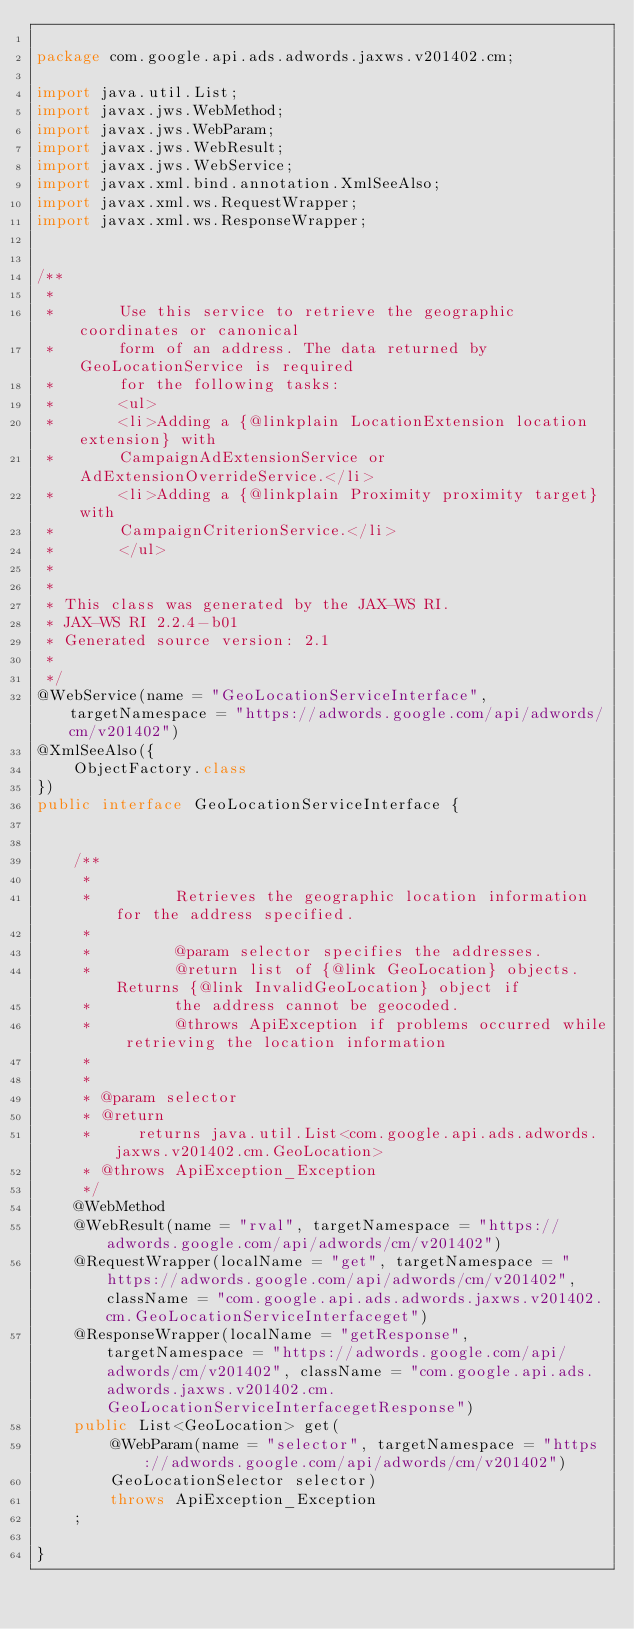Convert code to text. <code><loc_0><loc_0><loc_500><loc_500><_Java_>
package com.google.api.ads.adwords.jaxws.v201402.cm;

import java.util.List;
import javax.jws.WebMethod;
import javax.jws.WebParam;
import javax.jws.WebResult;
import javax.jws.WebService;
import javax.xml.bind.annotation.XmlSeeAlso;
import javax.xml.ws.RequestWrapper;
import javax.xml.ws.ResponseWrapper;


/**
 * 
 *       Use this service to retrieve the geographic coordinates or canonical
 *       form of an address. The data returned by GeoLocationService is required
 *       for the following tasks:
 *       <ul>
 *       <li>Adding a {@linkplain LocationExtension location extension} with
 *       CampaignAdExtensionService or AdExtensionOverrideService.</li>
 *       <li>Adding a {@linkplain Proximity proximity target} with
 *       CampaignCriterionService.</li>
 *       </ul>
 *     
 * 
 * This class was generated by the JAX-WS RI.
 * JAX-WS RI 2.2.4-b01
 * Generated source version: 2.1
 * 
 */
@WebService(name = "GeoLocationServiceInterface", targetNamespace = "https://adwords.google.com/api/adwords/cm/v201402")
@XmlSeeAlso({
    ObjectFactory.class
})
public interface GeoLocationServiceInterface {


    /**
     * 
     *         Retrieves the geographic location information for the address specified.
     *         
     *         @param selector specifies the addresses.
     *         @return list of {@link GeoLocation} objects. Returns {@link InvalidGeoLocation} object if
     *         the address cannot be geocoded.
     *         @throws ApiException if problems occurred while retrieving the location information
     *       
     * 
     * @param selector
     * @return
     *     returns java.util.List<com.google.api.ads.adwords.jaxws.v201402.cm.GeoLocation>
     * @throws ApiException_Exception
     */
    @WebMethod
    @WebResult(name = "rval", targetNamespace = "https://adwords.google.com/api/adwords/cm/v201402")
    @RequestWrapper(localName = "get", targetNamespace = "https://adwords.google.com/api/adwords/cm/v201402", className = "com.google.api.ads.adwords.jaxws.v201402.cm.GeoLocationServiceInterfaceget")
    @ResponseWrapper(localName = "getResponse", targetNamespace = "https://adwords.google.com/api/adwords/cm/v201402", className = "com.google.api.ads.adwords.jaxws.v201402.cm.GeoLocationServiceInterfacegetResponse")
    public List<GeoLocation> get(
        @WebParam(name = "selector", targetNamespace = "https://adwords.google.com/api/adwords/cm/v201402")
        GeoLocationSelector selector)
        throws ApiException_Exception
    ;

}
</code> 